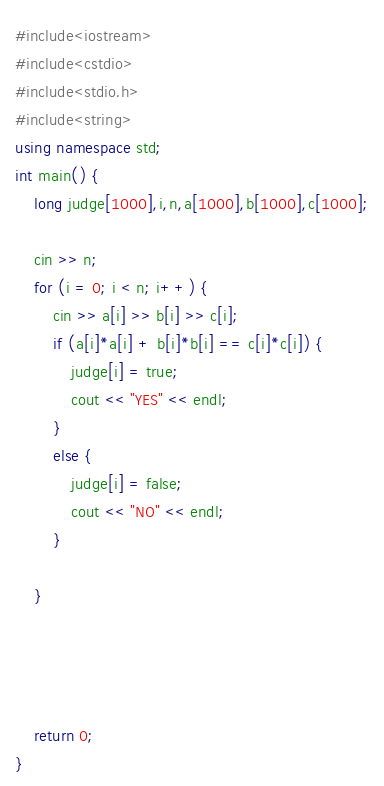<code> <loc_0><loc_0><loc_500><loc_500><_C++_>#include<iostream>
#include<cstdio>
#include<stdio.h>
#include<string>
using namespace std;
int main() {
	long judge[1000],i,n,a[1000],b[1000],c[1000];

	cin >> n;
	for (i = 0; i < n; i++) {
		cin >> a[i] >> b[i] >> c[i];
		if (a[i]*a[i] + b[i]*b[i] == c[i]*c[i]) {
			judge[i] = true;
			cout << "YES" << endl;
		}
		else {
			judge[i] = false;
			cout << "NO" << endl;
		}

	}
	
	
	

	return 0;
}</code> 